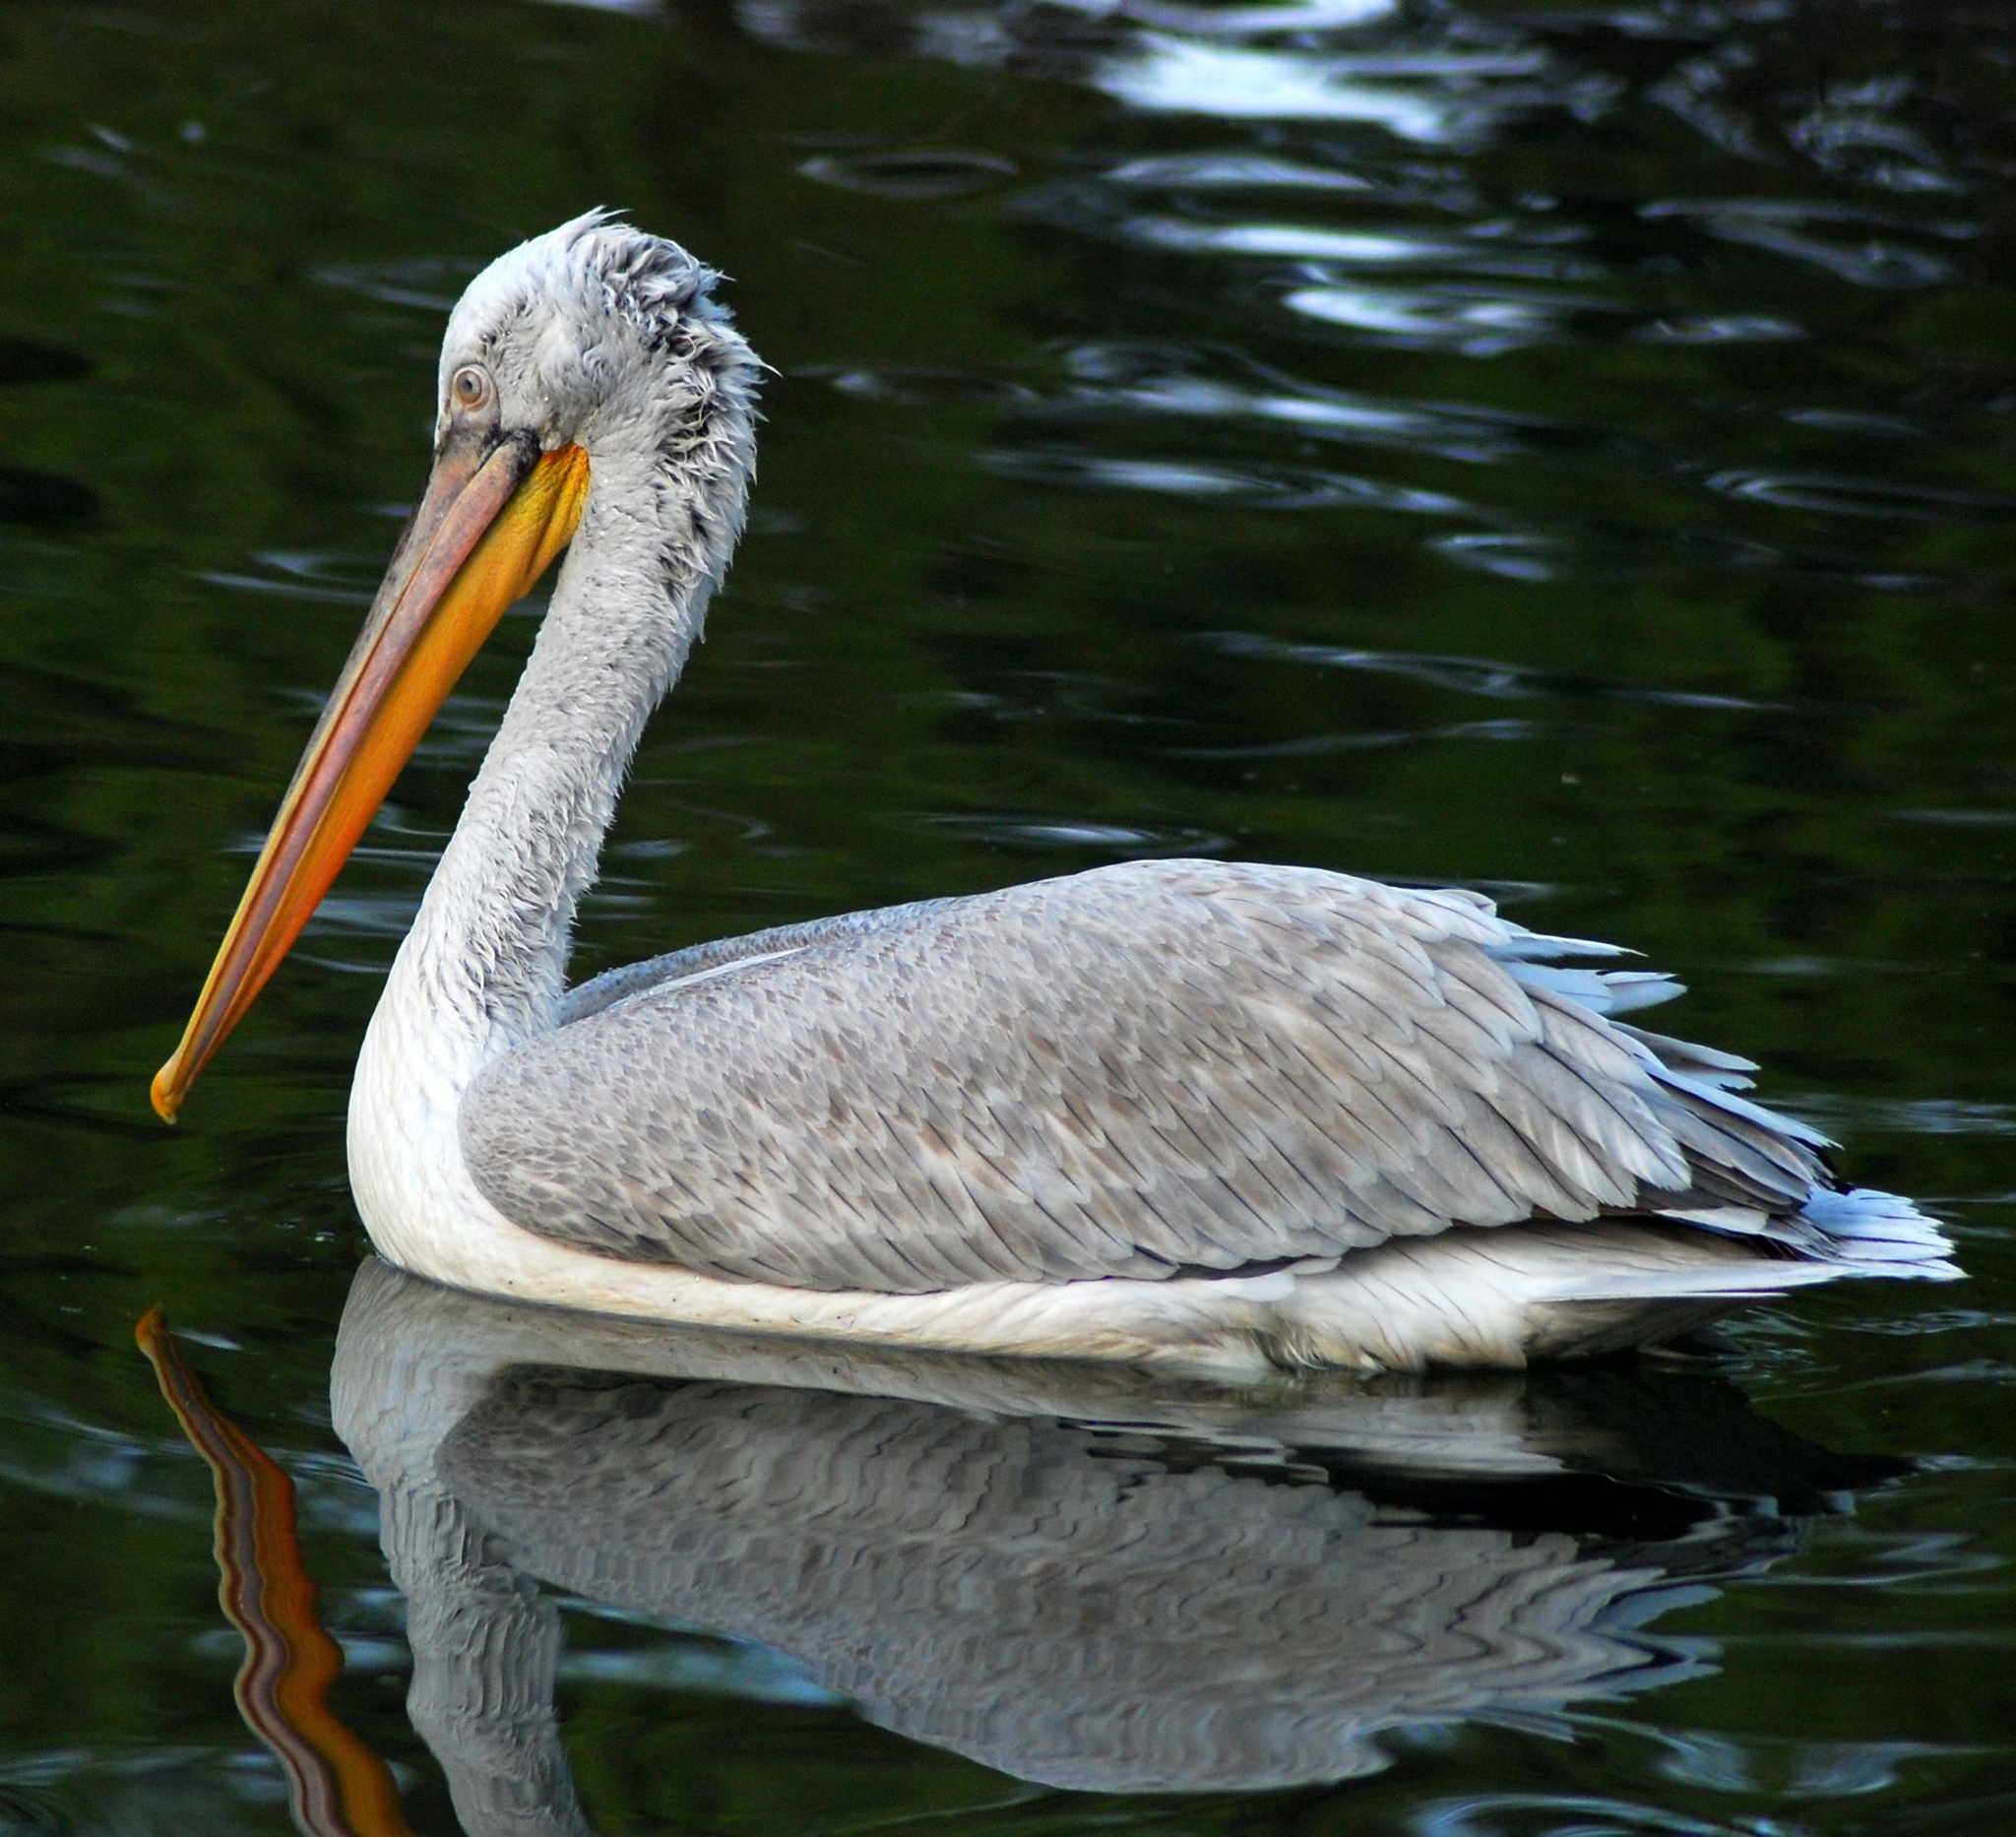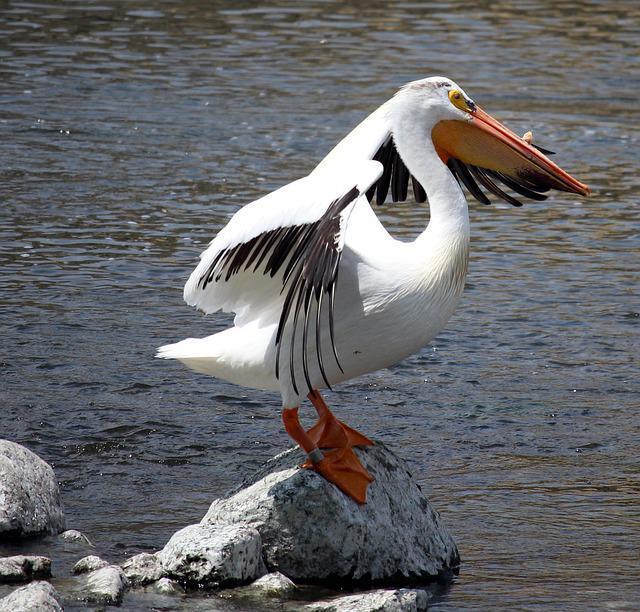The first image is the image on the left, the second image is the image on the right. Considering the images on both sides, is "There is a pelican flying in the air." valid? Answer yes or no. No. 